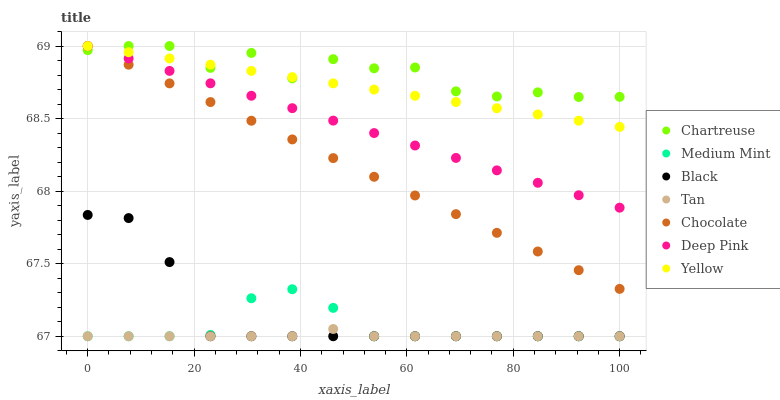Does Tan have the minimum area under the curve?
Answer yes or no. Yes. Does Chartreuse have the maximum area under the curve?
Answer yes or no. Yes. Does Deep Pink have the minimum area under the curve?
Answer yes or no. No. Does Deep Pink have the maximum area under the curve?
Answer yes or no. No. Is Yellow the smoothest?
Answer yes or no. Yes. Is Chartreuse the roughest?
Answer yes or no. Yes. Is Deep Pink the smoothest?
Answer yes or no. No. Is Deep Pink the roughest?
Answer yes or no. No. Does Medium Mint have the lowest value?
Answer yes or no. Yes. Does Deep Pink have the lowest value?
Answer yes or no. No. Does Chartreuse have the highest value?
Answer yes or no. Yes. Does Black have the highest value?
Answer yes or no. No. Is Medium Mint less than Chartreuse?
Answer yes or no. Yes. Is Yellow greater than Black?
Answer yes or no. Yes. Does Yellow intersect Chocolate?
Answer yes or no. Yes. Is Yellow less than Chocolate?
Answer yes or no. No. Is Yellow greater than Chocolate?
Answer yes or no. No. Does Medium Mint intersect Chartreuse?
Answer yes or no. No. 